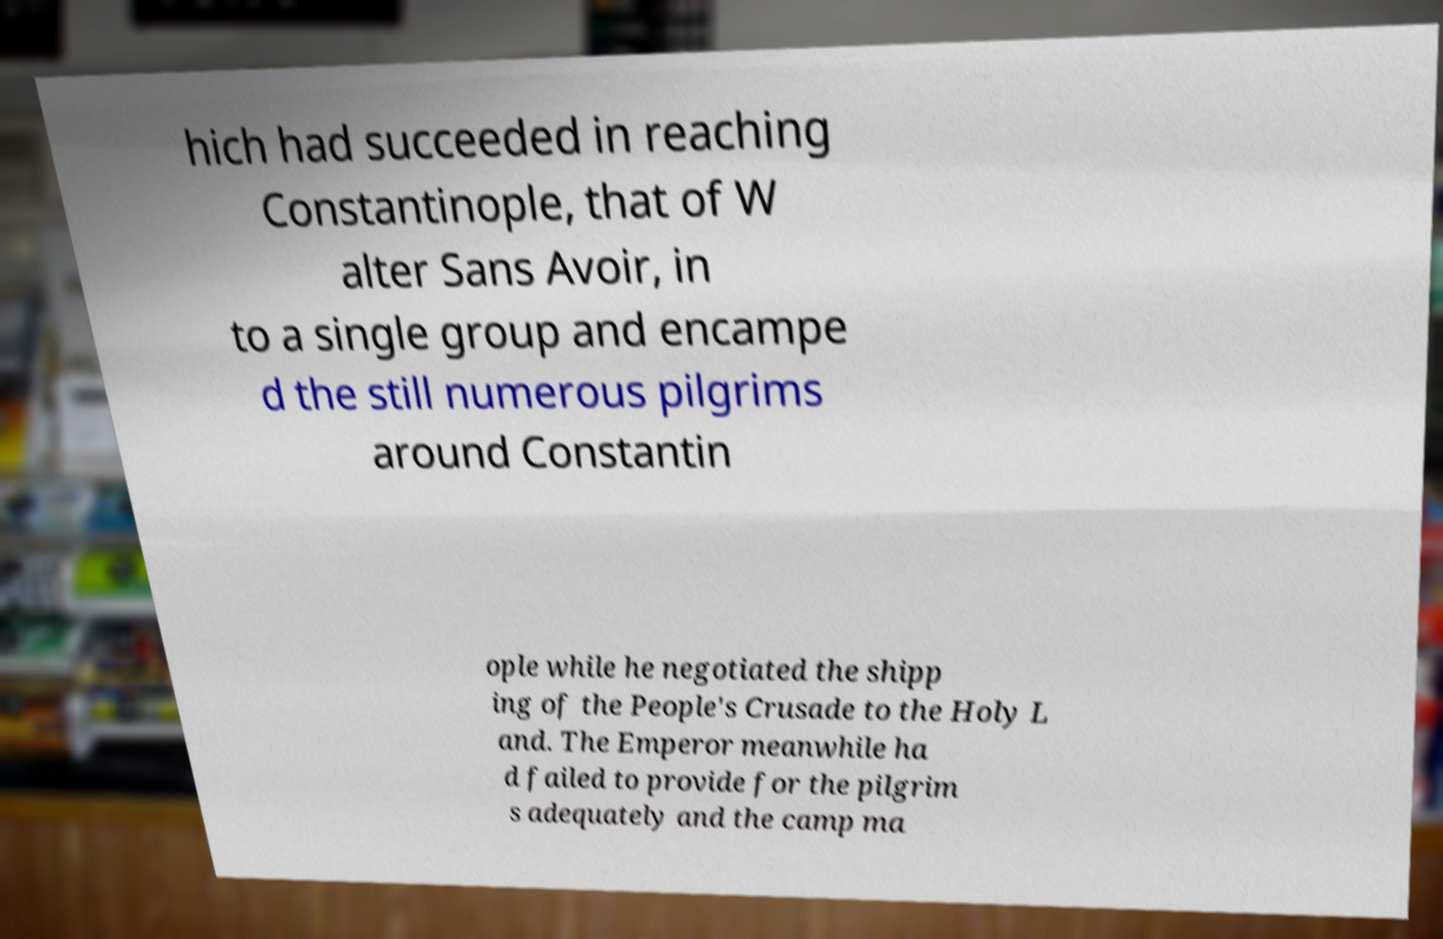What messages or text are displayed in this image? I need them in a readable, typed format. hich had succeeded in reaching Constantinople, that of W alter Sans Avoir, in to a single group and encampe d the still numerous pilgrims around Constantin ople while he negotiated the shipp ing of the People's Crusade to the Holy L and. The Emperor meanwhile ha d failed to provide for the pilgrim s adequately and the camp ma 